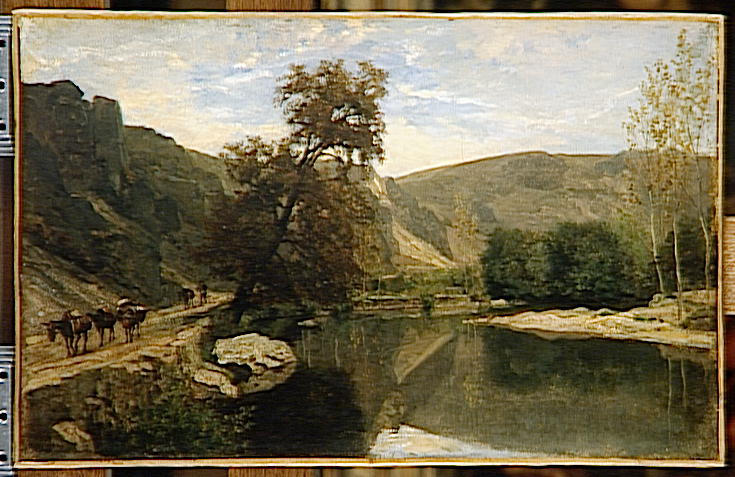What story do you think is unfolding in this landscape scene? This scene tells the story of a quiet rural life where nature and humans exist harmoniously. The presence of cows suggests a pastoral lifestyle, perhaps a farmer nearby guiding his herd to graze. The river serves as a tranquil passage, possibly the lifeline of the community, providing fresh water. The rugged cliffs in the background contrast with the serene water, hinting at the resilience and strength required to sustain life in this landscape. What time of day do you think it is in the painting? The soft lighting and the gentle shadows cast by the trees suggest that it could be either early morning or late afternoon. During these times, the sun is lower in the sky, giving the landscape a warm and inviting glow, enhancing the serene and peaceful atmosphere. Can you describe the atmosphere if a storm were approaching? If a storm were approaching, the atmosphere would drastically change. The serene blue sky would be replaced by dark, ominous clouds gathering on the horizon. The gentle breeze would turn into a gusty wind, rustling the leaves and causing ripples on the calm river. The cows might start moving hurriedly to find shelter, and the entire scene would take on a sense of urgency and foreboding. The colors might become darker and more muted, capturing the tense anticipation of the storm.  If those cliffs were home to mythical creatures, what kind would they be? Imagine the cliffs are home to ancient, gentle giants who have watched over the valley for millennia. These mythical creatures, resembling massive stone beings, blend seamlessly into the rugged rock face, almost indistinguishable from the cliffs themselves. They emerge at dusk and dawn, their movements slow and deliberate as they tend to the land, ensuring the balance of nature is maintained. Their presence goes unnoticed by the cows and the occasional passerby, but legends in the nearby villages speak of these guardians and their ancient wisdom. 